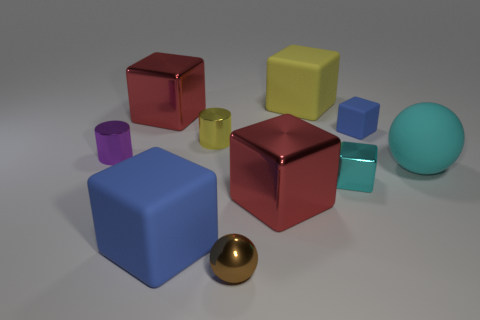How many metallic things are the same color as the large sphere?
Ensure brevity in your answer.  1. How many objects are yellow blocks or metal balls?
Make the answer very short. 2. What shape is the yellow rubber object that is the same size as the cyan sphere?
Provide a short and direct response. Cube. How many blue blocks are both right of the tiny metal block and on the left side of the small yellow shiny cylinder?
Provide a short and direct response. 0. There is a blue block on the right side of the large yellow block; what is its material?
Make the answer very short. Rubber. There is a brown thing that is the same material as the purple object; what is its size?
Make the answer very short. Small. Do the red metal block that is in front of the cyan matte object and the matte cube left of the yellow metal thing have the same size?
Provide a succinct answer. Yes. What is the material of the yellow thing that is the same size as the cyan sphere?
Keep it short and to the point. Rubber. There is a small thing that is to the right of the small metal sphere and to the left of the small blue rubber thing; what material is it made of?
Provide a short and direct response. Metal. Are there any large shiny objects?
Offer a very short reply. Yes. 